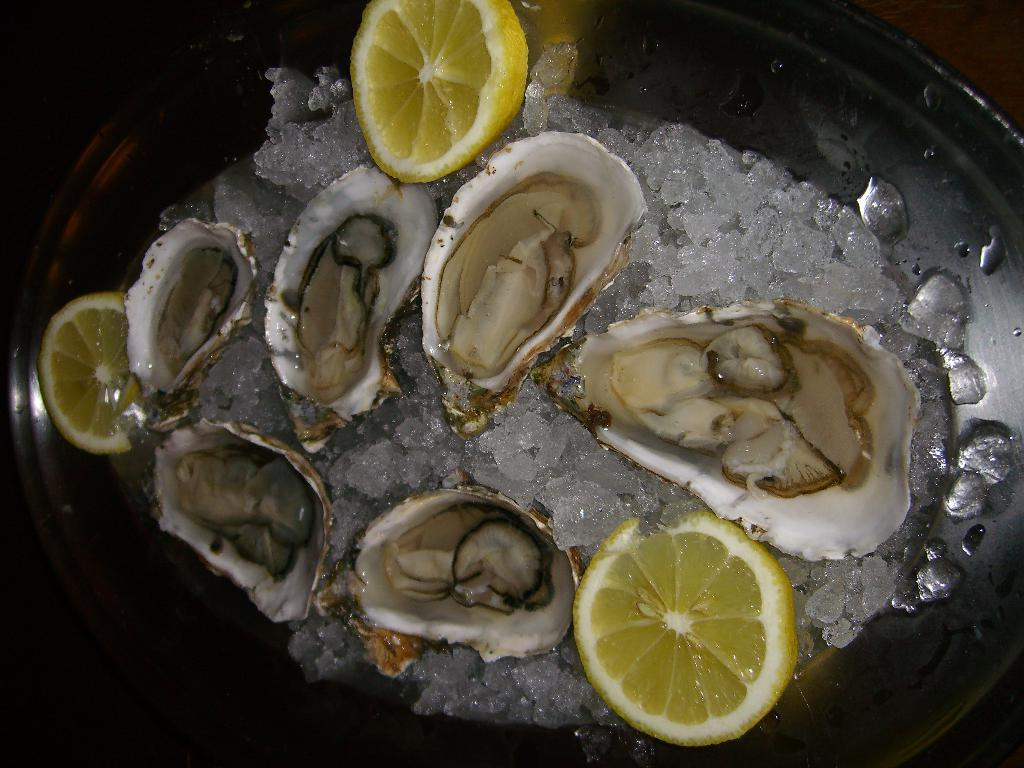What type of seafood is present in the image? There are oysters in the image. What fruit is also visible in the image? There are lemons in the image. What is used to keep the oysters and lemons cold in the image? There is ice in the image. How are the oysters, lemons, and ice arranged in the image? The oysters, lemons, and ice are in a plate. Where is the plate with the oysters, lemons, and ice located? The plate is placed on a table. What type of clover is growing on the table in the image? There is no clover present in the image; the plate with the oysters, lemons, and ice is placed on a table. How many nails can be seen holding the plate to the table in the image? There are no nails visible in the image; the plate is simply placed on the table. 